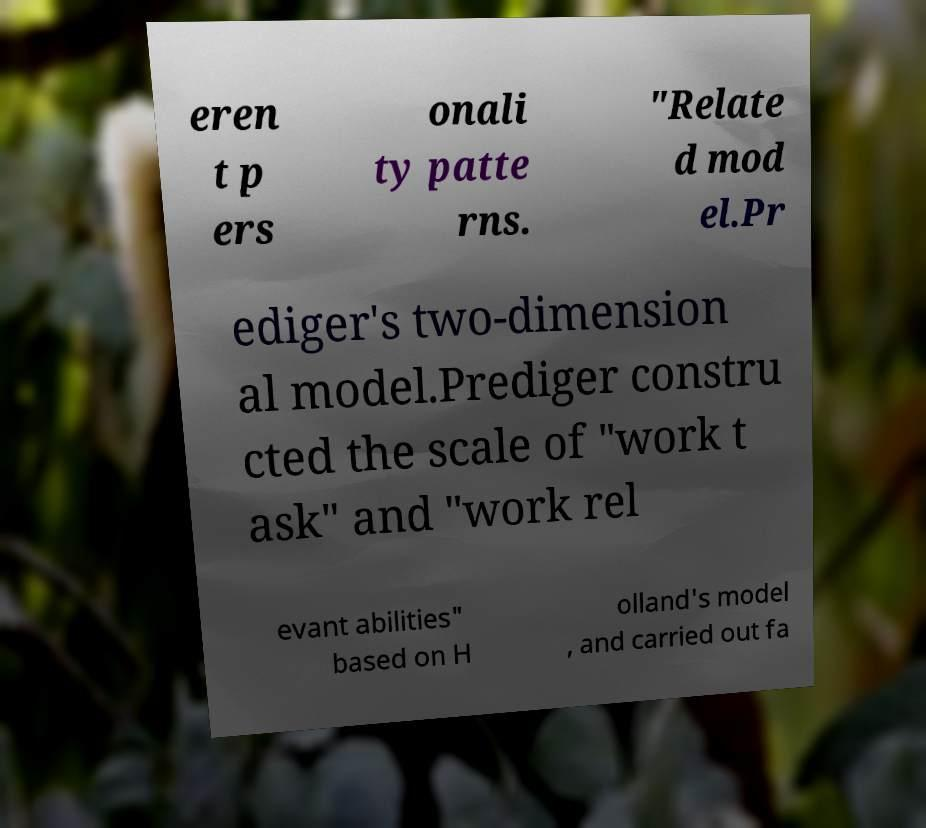What messages or text are displayed in this image? I need them in a readable, typed format. eren t p ers onali ty patte rns. "Relate d mod el.Pr ediger's two-dimension al model.Prediger constru cted the scale of "work t ask" and "work rel evant abilities" based on H olland's model , and carried out fa 